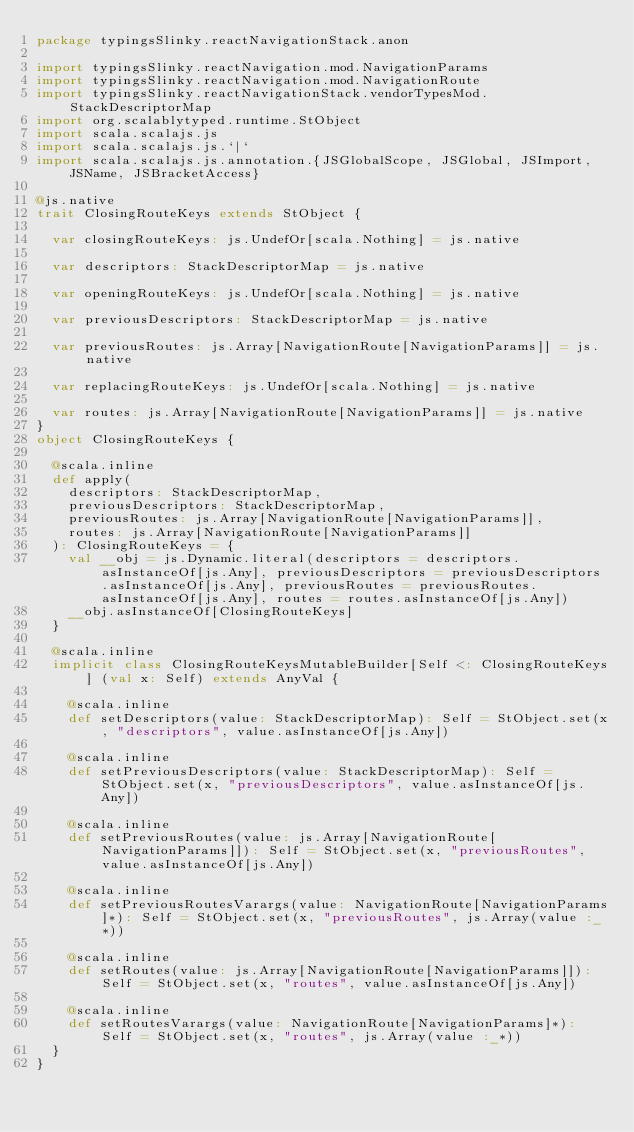<code> <loc_0><loc_0><loc_500><loc_500><_Scala_>package typingsSlinky.reactNavigationStack.anon

import typingsSlinky.reactNavigation.mod.NavigationParams
import typingsSlinky.reactNavigation.mod.NavigationRoute
import typingsSlinky.reactNavigationStack.vendorTypesMod.StackDescriptorMap
import org.scalablytyped.runtime.StObject
import scala.scalajs.js
import scala.scalajs.js.`|`
import scala.scalajs.js.annotation.{JSGlobalScope, JSGlobal, JSImport, JSName, JSBracketAccess}

@js.native
trait ClosingRouteKeys extends StObject {
  
  var closingRouteKeys: js.UndefOr[scala.Nothing] = js.native
  
  var descriptors: StackDescriptorMap = js.native
  
  var openingRouteKeys: js.UndefOr[scala.Nothing] = js.native
  
  var previousDescriptors: StackDescriptorMap = js.native
  
  var previousRoutes: js.Array[NavigationRoute[NavigationParams]] = js.native
  
  var replacingRouteKeys: js.UndefOr[scala.Nothing] = js.native
  
  var routes: js.Array[NavigationRoute[NavigationParams]] = js.native
}
object ClosingRouteKeys {
  
  @scala.inline
  def apply(
    descriptors: StackDescriptorMap,
    previousDescriptors: StackDescriptorMap,
    previousRoutes: js.Array[NavigationRoute[NavigationParams]],
    routes: js.Array[NavigationRoute[NavigationParams]]
  ): ClosingRouteKeys = {
    val __obj = js.Dynamic.literal(descriptors = descriptors.asInstanceOf[js.Any], previousDescriptors = previousDescriptors.asInstanceOf[js.Any], previousRoutes = previousRoutes.asInstanceOf[js.Any], routes = routes.asInstanceOf[js.Any])
    __obj.asInstanceOf[ClosingRouteKeys]
  }
  
  @scala.inline
  implicit class ClosingRouteKeysMutableBuilder[Self <: ClosingRouteKeys] (val x: Self) extends AnyVal {
    
    @scala.inline
    def setDescriptors(value: StackDescriptorMap): Self = StObject.set(x, "descriptors", value.asInstanceOf[js.Any])
    
    @scala.inline
    def setPreviousDescriptors(value: StackDescriptorMap): Self = StObject.set(x, "previousDescriptors", value.asInstanceOf[js.Any])
    
    @scala.inline
    def setPreviousRoutes(value: js.Array[NavigationRoute[NavigationParams]]): Self = StObject.set(x, "previousRoutes", value.asInstanceOf[js.Any])
    
    @scala.inline
    def setPreviousRoutesVarargs(value: NavigationRoute[NavigationParams]*): Self = StObject.set(x, "previousRoutes", js.Array(value :_*))
    
    @scala.inline
    def setRoutes(value: js.Array[NavigationRoute[NavigationParams]]): Self = StObject.set(x, "routes", value.asInstanceOf[js.Any])
    
    @scala.inline
    def setRoutesVarargs(value: NavigationRoute[NavigationParams]*): Self = StObject.set(x, "routes", js.Array(value :_*))
  }
}
</code> 